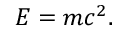Convert formula to latex. <formula><loc_0><loc_0><loc_500><loc_500>E = m c ^ { 2 } .</formula> 